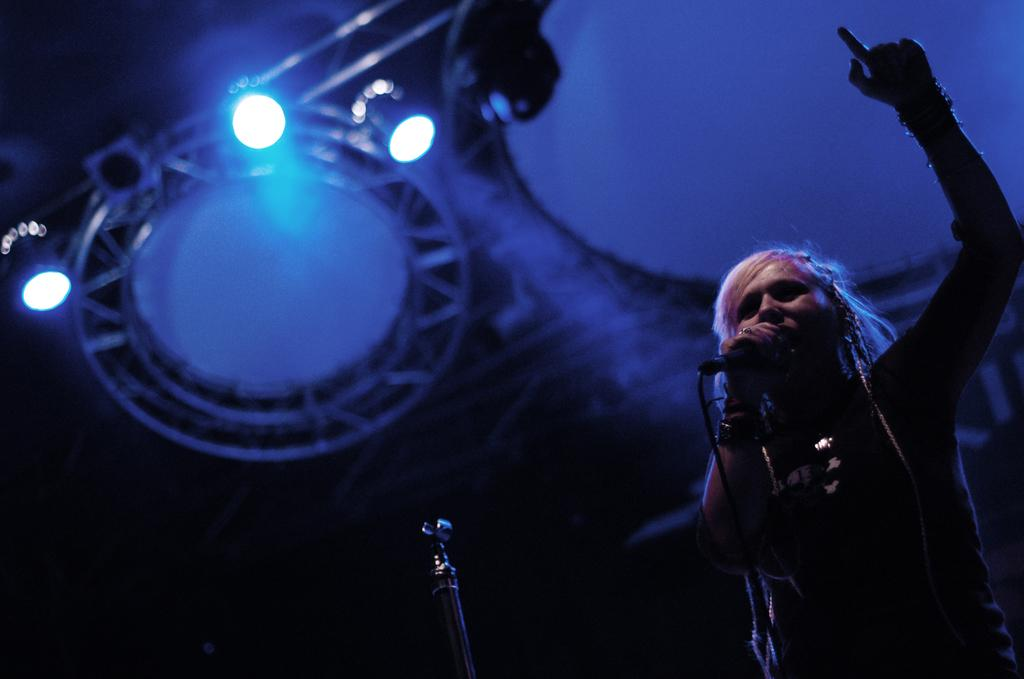Who is present in the image? There is a person in the image. What is the person doing in the image? The person is standing and holding a mic in their hand. What can be seen in the background of the image? There are electric lights and grills in the background of the image. How many rings is the person wearing on their left hand in the image? There is no mention of rings in the image, so we cannot determine how many rings the person is wearing. 